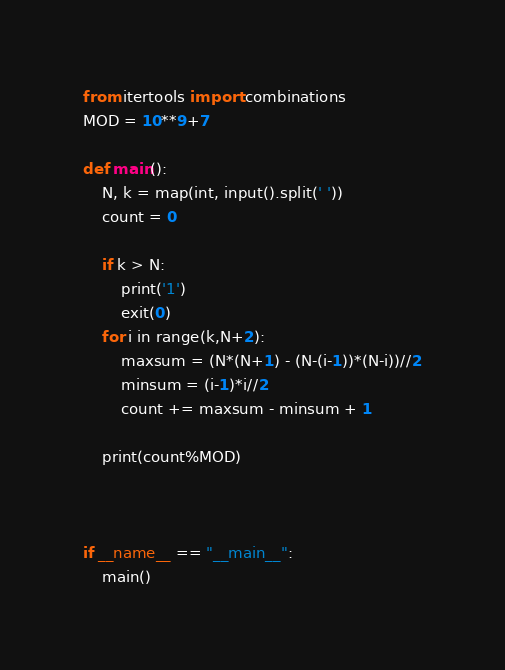<code> <loc_0><loc_0><loc_500><loc_500><_Python_>from itertools import combinations
MOD = 10**9+7

def main():
    N, k = map(int, input().split(' '))
    count = 0

    if k > N:
        print('1')
        exit(0)
    for i in range(k,N+2):
        maxsum = (N*(N+1) - (N-(i-1))*(N-i))//2
        minsum = (i-1)*i//2
        count += maxsum - minsum + 1

    print(count%MOD)



if __name__ == "__main__":
    main()
</code> 